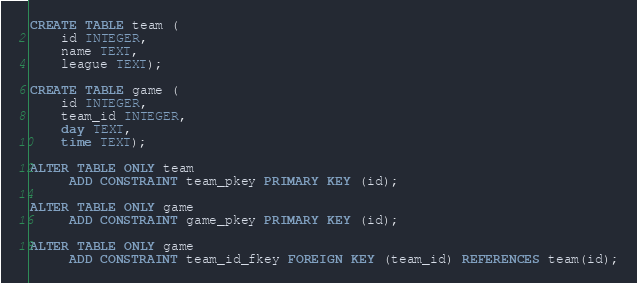<code> <loc_0><loc_0><loc_500><loc_500><_SQL_>CREATE TABLE team (
    id INTEGER,
    name TEXT,
    league TEXT);

CREATE TABLE game (
    id INTEGER,
    team_id INTEGER,
    day TEXT,
    time TEXT);

ALTER TABLE ONLY team
     ADD CONSTRAINT team_pkey PRIMARY KEY (id);

ALTER TABLE ONLY game
     ADD CONSTRAINT game_pkey PRIMARY KEY (id);

ALTER TABLE ONLY game
     ADD CONSTRAINT team_id_fkey FOREIGN KEY (team_id) REFERENCES team(id);
</code> 